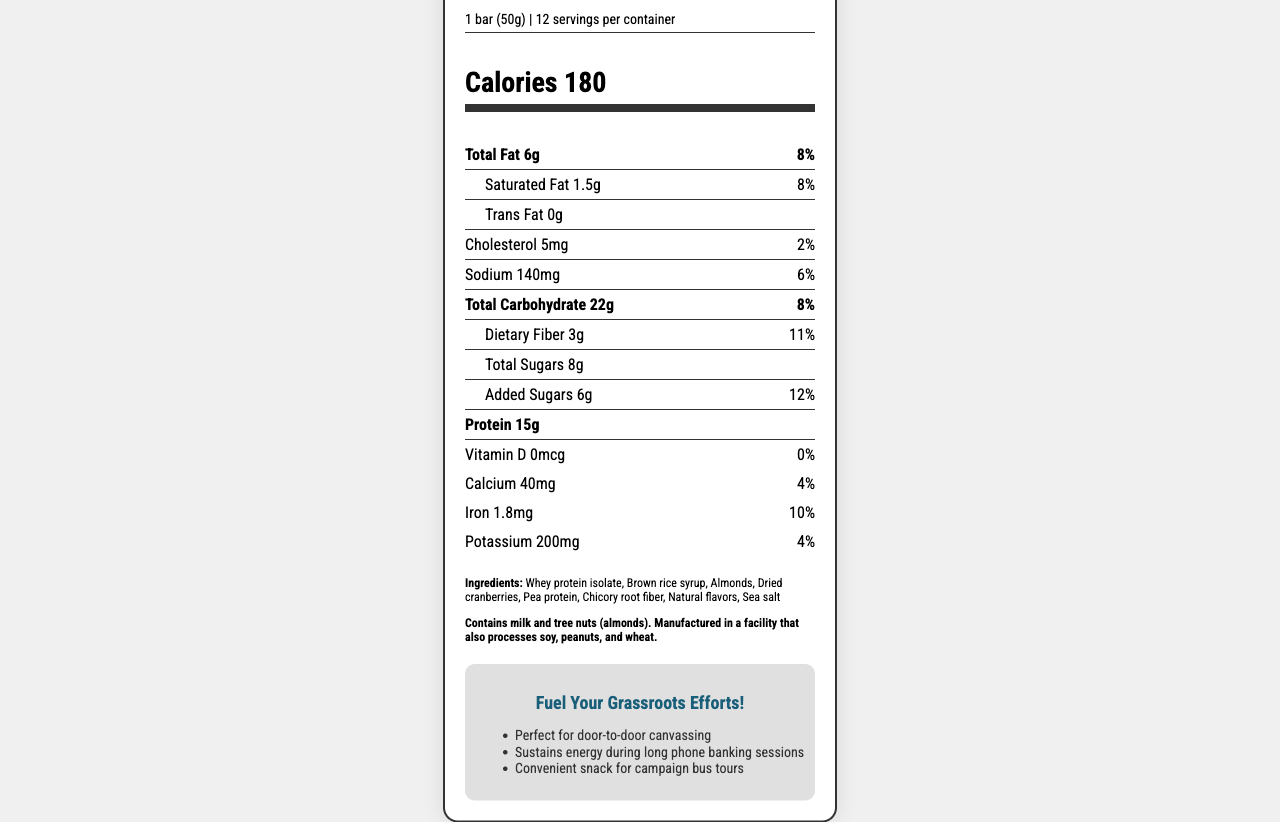What is the serving size for the Campaign Trail Energy Bar? The serving size is clearly listed at the top of the Nutrition Facts label.
Answer: 1 bar (50g) How many calories are there per serving? The calories per serving are prominently displayed in the "Calories" section.
Answer: 180 What is the total fat content per serving? The total fat content is listed in the "Total Fat" section with the amount being 6g.
Answer: 6g How much protein is in each bar? The protein content is listed in the "Protein" section as 15g per bar.
Answer: 15g What are the primary ingredients of the Campaign Trail Energy Bar? The ingredients are listed at the bottom of the Nutrition Facts label under "Ingredients."
Answer: Whey protein isolate, Brown rice syrup, Almonds, Dried cranberries, Pea protein, Chicory root fiber, Natural flavors, Sea salt What percentage of the daily value of Saturated Fat does one serving contain? The daily value percentage for Saturated Fat is listed next to its amount (1.5g) under "Saturated Fat."
Answer: 8% How much sodium is in each serving of the Campaign Trail Energy Bar? The sodium content is listed in the "Sodium" section with the amount being 140mg.
Answer: 140mg Which vitamin or mineral has the highest daily value percentage in this bar? A. Vitamin D B. Calcium C. Iron D. Potassium The daily value percentages in the "Vitamin" section show Iron at 10%, which is higher than other listed vitamins and minerals.
Answer: C. Iron Which of the following claims is made about the Campaign Trail Energy Bar? A. Low in Carbs B. Gluten-Free C. Perfect for door-to-door canvassing D. High in Vitamin D The marketing claims listed in the document include "Perfect for door-to-door canvassing."
Answer: C. Perfect for door-to-door canvassing Does the Campaign Trail Energy Bar contain any trans fat? The document specifically lists "Trans Fat 0g," indicating there is no trans fat.
Answer: No Describe the main idea of the document. The document contains detailed nutritional facts, ingredients, allergen information, marketing claims, and convenience details suited for campaign volunteer needs.
Answer: The Campaign Trail Energy Bar is a nutrition-focused product designed to support campaign volunteers through its balanced nutritional profile and convenient packaging. The document provides detailed nutritional information, ingredients, allergen warnings, and marketing claims to highlight its benefits. Can you determine the price of the Campaign Trail Energy Bar from this document? The document does not provide any information regarding the price of the bar.
Answer: Cannot be determined What is the daily value percentage of dietary fiber in a serving? The daily value percentage for dietary fiber is listed next to its amount (3g) under "Dietary Fiber."
Answer: 11% What allergen information is provided for the Campaign Trail Energy Bar? The allergen information is explicitly stated at the bottom of the ingredient list in the document.
Answer: Contains milk and tree nuts (almonds). Manufactured in a facility that also processes soy, peanuts, and wheat. What is the sodium content in each serving? A. 100mg B. 140mg C. 180mg D. 220mg The sodium content per serving is listed at 140mg under the "Sodium" section.
Answer: B. 140mg Is the Campaign Trail Energy Bar high in added sugars? The bar contains 6g of added sugars, which is 12% of the daily value, and is not considered high in added sugars.
Answer: No 